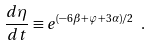Convert formula to latex. <formula><loc_0><loc_0><loc_500><loc_500>\frac { d \eta } { d t } \equiv e ^ { ( - 6 \beta + \varphi + 3 \alpha ) / 2 } \ .</formula> 